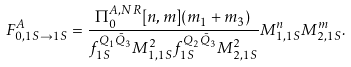<formula> <loc_0><loc_0><loc_500><loc_500>F _ { 0 , 1 S \to 1 S } ^ { A } = \frac { \Pi _ { 0 } ^ { A , N R } [ n , m ] ( m _ { 1 } + m _ { 3 } ) } { f _ { 1 S } ^ { Q _ { 1 } \bar { Q } _ { 3 } } M _ { 1 , 1 S } ^ { 2 } f _ { 1 S } ^ { Q _ { 2 } \bar { Q } _ { 3 } } M _ { 2 , 1 S } ^ { 2 } } M _ { 1 , 1 S } ^ { n } M _ { 2 , 1 S } ^ { m } .</formula> 